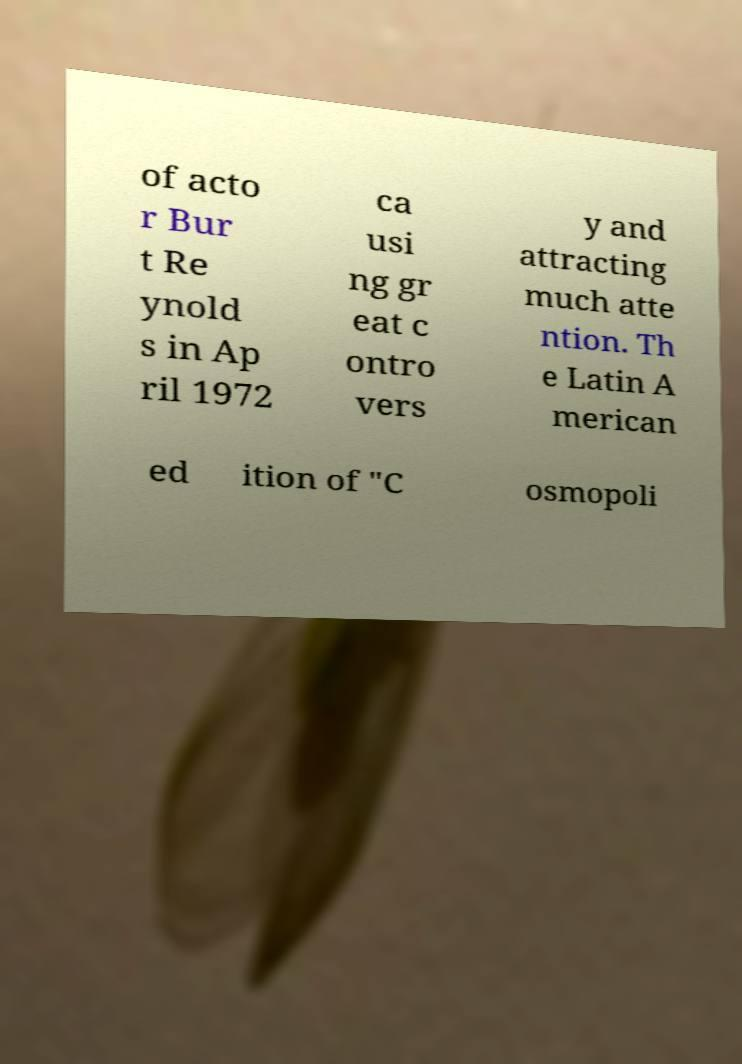Could you extract and type out the text from this image? of acto r Bur t Re ynold s in Ap ril 1972 ca usi ng gr eat c ontro vers y and attracting much atte ntion. Th e Latin A merican ed ition of "C osmopoli 